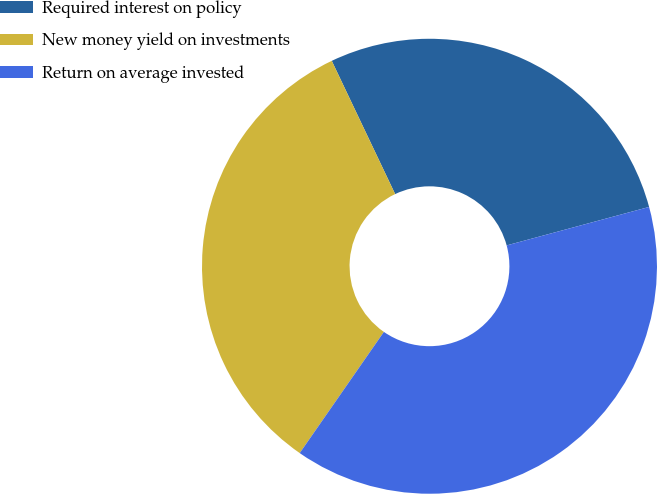Convert chart to OTSL. <chart><loc_0><loc_0><loc_500><loc_500><pie_chart><fcel>Required interest on policy<fcel>New money yield on investments<fcel>Return on average invested<nl><fcel>27.87%<fcel>33.27%<fcel>38.86%<nl></chart> 